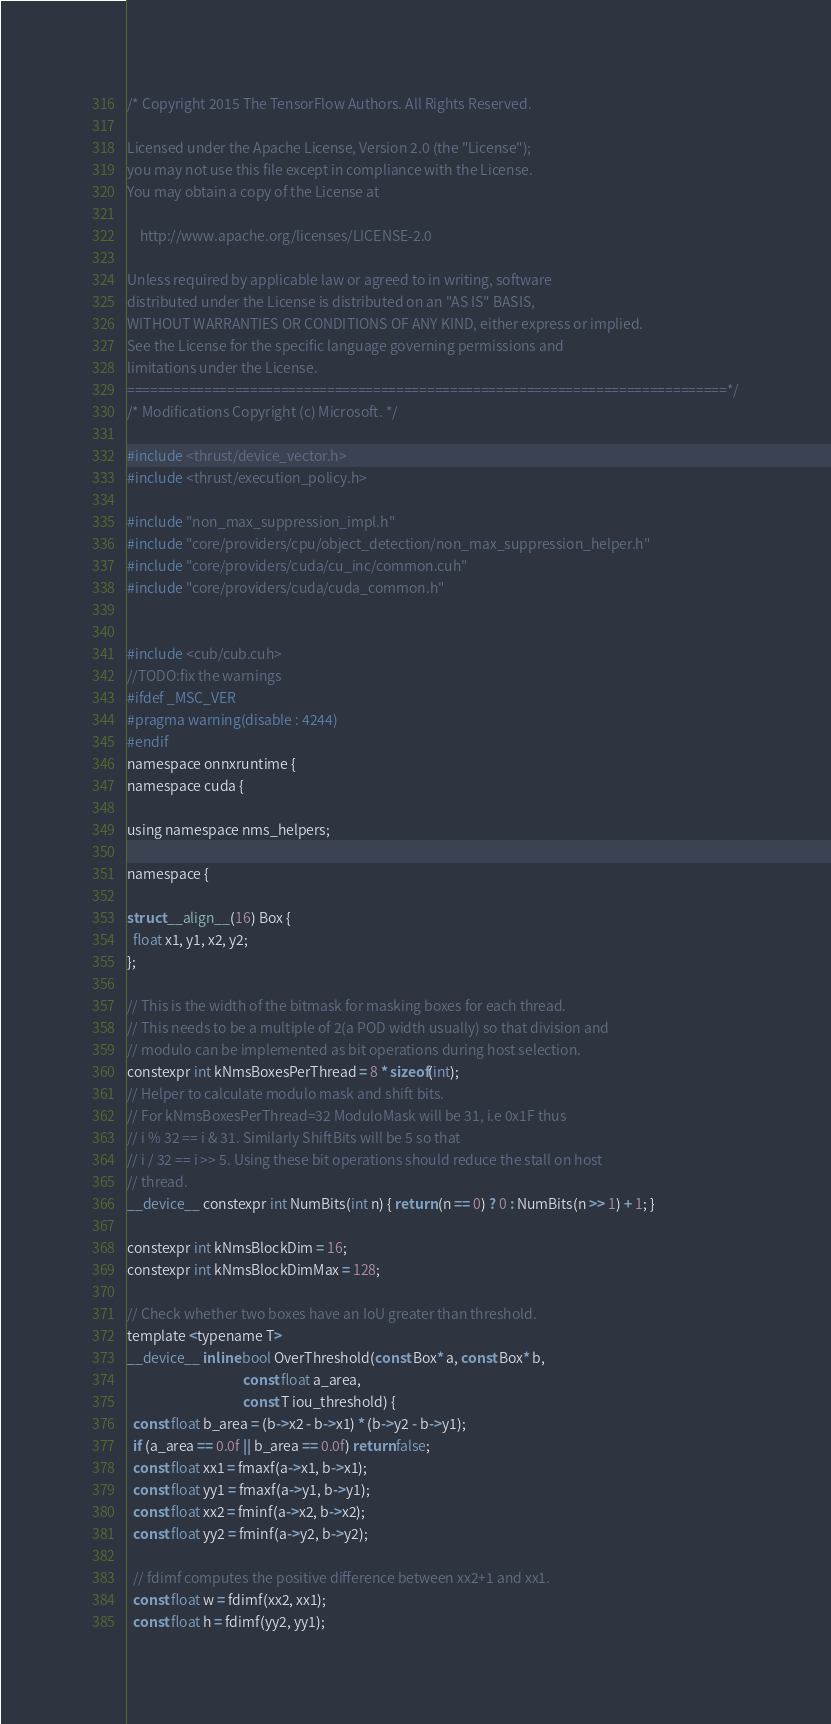Convert code to text. <code><loc_0><loc_0><loc_500><loc_500><_Cuda_>/* Copyright 2015 The TensorFlow Authors. All Rights Reserved.

Licensed under the Apache License, Version 2.0 (the "License");
you may not use this file except in compliance with the License.
You may obtain a copy of the License at

    http://www.apache.org/licenses/LICENSE-2.0

Unless required by applicable law or agreed to in writing, software
distributed under the License is distributed on an "AS IS" BASIS,
WITHOUT WARRANTIES OR CONDITIONS OF ANY KIND, either express or implied.
See the License for the specific language governing permissions and
limitations under the License.
==============================================================================*/
/* Modifications Copyright (c) Microsoft. */

#include <thrust/device_vector.h>
#include <thrust/execution_policy.h>

#include "non_max_suppression_impl.h"
#include "core/providers/cpu/object_detection/non_max_suppression_helper.h"
#include "core/providers/cuda/cu_inc/common.cuh"
#include "core/providers/cuda/cuda_common.h"


#include <cub/cub.cuh>
//TODO:fix the warnings
#ifdef _MSC_VER
#pragma warning(disable : 4244)
#endif
namespace onnxruntime {
namespace cuda {

using namespace nms_helpers;

namespace {

struct __align__(16) Box {
  float x1, y1, x2, y2;
};

// This is the width of the bitmask for masking boxes for each thread.
// This needs to be a multiple of 2(a POD width usually) so that division and
// modulo can be implemented as bit operations during host selection.
constexpr int kNmsBoxesPerThread = 8 * sizeof(int);
// Helper to calculate modulo mask and shift bits.
// For kNmsBoxesPerThread=32 ModuloMask will be 31, i.e 0x1F thus
// i % 32 == i & 31. Similarly ShiftBits will be 5 so that
// i / 32 == i >> 5. Using these bit operations should reduce the stall on host
// thread.
__device__ constexpr int NumBits(int n) { return (n == 0) ? 0 : NumBits(n >> 1) + 1; }

constexpr int kNmsBlockDim = 16;
constexpr int kNmsBlockDimMax = 128;

// Check whether two boxes have an IoU greater than threshold.
template <typename T>
__device__ inline bool OverThreshold(const Box* a, const Box* b,
                                     const float a_area,
                                     const T iou_threshold) {
  const float b_area = (b->x2 - b->x1) * (b->y2 - b->y1);
  if (a_area == 0.0f || b_area == 0.0f) return false;
  const float xx1 = fmaxf(a->x1, b->x1);
  const float yy1 = fmaxf(a->y1, b->y1);
  const float xx2 = fminf(a->x2, b->x2);
  const float yy2 = fminf(a->y2, b->y2);

  // fdimf computes the positive difference between xx2+1 and xx1.
  const float w = fdimf(xx2, xx1);
  const float h = fdimf(yy2, yy1);</code> 